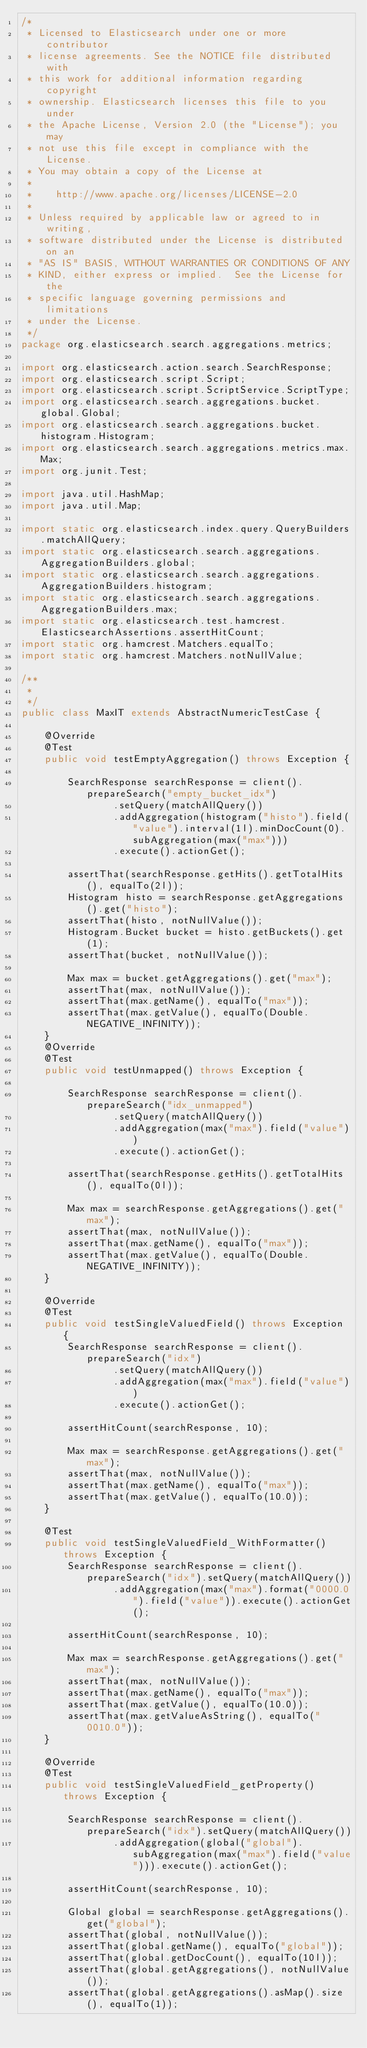Convert code to text. <code><loc_0><loc_0><loc_500><loc_500><_Java_>/*
 * Licensed to Elasticsearch under one or more contributor
 * license agreements. See the NOTICE file distributed with
 * this work for additional information regarding copyright
 * ownership. Elasticsearch licenses this file to you under
 * the Apache License, Version 2.0 (the "License"); you may
 * not use this file except in compliance with the License.
 * You may obtain a copy of the License at
 *
 *    http://www.apache.org/licenses/LICENSE-2.0
 *
 * Unless required by applicable law or agreed to in writing,
 * software distributed under the License is distributed on an
 * "AS IS" BASIS, WITHOUT WARRANTIES OR CONDITIONS OF ANY
 * KIND, either express or implied.  See the License for the
 * specific language governing permissions and limitations
 * under the License.
 */
package org.elasticsearch.search.aggregations.metrics;

import org.elasticsearch.action.search.SearchResponse;
import org.elasticsearch.script.Script;
import org.elasticsearch.script.ScriptService.ScriptType;
import org.elasticsearch.search.aggregations.bucket.global.Global;
import org.elasticsearch.search.aggregations.bucket.histogram.Histogram;
import org.elasticsearch.search.aggregations.metrics.max.Max;
import org.junit.Test;

import java.util.HashMap;
import java.util.Map;

import static org.elasticsearch.index.query.QueryBuilders.matchAllQuery;
import static org.elasticsearch.search.aggregations.AggregationBuilders.global;
import static org.elasticsearch.search.aggregations.AggregationBuilders.histogram;
import static org.elasticsearch.search.aggregations.AggregationBuilders.max;
import static org.elasticsearch.test.hamcrest.ElasticsearchAssertions.assertHitCount;
import static org.hamcrest.Matchers.equalTo;
import static org.hamcrest.Matchers.notNullValue;

/**
 *
 */
public class MaxIT extends AbstractNumericTestCase {

    @Override
    @Test
    public void testEmptyAggregation() throws Exception {

        SearchResponse searchResponse = client().prepareSearch("empty_bucket_idx")
                .setQuery(matchAllQuery())
                .addAggregation(histogram("histo").field("value").interval(1l).minDocCount(0).subAggregation(max("max")))
                .execute().actionGet();

        assertThat(searchResponse.getHits().getTotalHits(), equalTo(2l));
        Histogram histo = searchResponse.getAggregations().get("histo");
        assertThat(histo, notNullValue());
        Histogram.Bucket bucket = histo.getBuckets().get(1);
        assertThat(bucket, notNullValue());

        Max max = bucket.getAggregations().get("max");
        assertThat(max, notNullValue());
        assertThat(max.getName(), equalTo("max"));
        assertThat(max.getValue(), equalTo(Double.NEGATIVE_INFINITY));
    }
    @Override
    @Test
    public void testUnmapped() throws Exception {

        SearchResponse searchResponse = client().prepareSearch("idx_unmapped")
                .setQuery(matchAllQuery())
                .addAggregation(max("max").field("value"))
                .execute().actionGet();

        assertThat(searchResponse.getHits().getTotalHits(), equalTo(0l));

        Max max = searchResponse.getAggregations().get("max");
        assertThat(max, notNullValue());
        assertThat(max.getName(), equalTo("max"));
        assertThat(max.getValue(), equalTo(Double.NEGATIVE_INFINITY));
    }

    @Override
    @Test
    public void testSingleValuedField() throws Exception {
        SearchResponse searchResponse = client().prepareSearch("idx")
                .setQuery(matchAllQuery())
                .addAggregation(max("max").field("value"))
                .execute().actionGet();

        assertHitCount(searchResponse, 10);

        Max max = searchResponse.getAggregations().get("max");
        assertThat(max, notNullValue());
        assertThat(max.getName(), equalTo("max"));
        assertThat(max.getValue(), equalTo(10.0));
    }

    @Test
    public void testSingleValuedField_WithFormatter() throws Exception {
        SearchResponse searchResponse = client().prepareSearch("idx").setQuery(matchAllQuery())
                .addAggregation(max("max").format("0000.0").field("value")).execute().actionGet();

        assertHitCount(searchResponse, 10);

        Max max = searchResponse.getAggregations().get("max");
        assertThat(max, notNullValue());
        assertThat(max.getName(), equalTo("max"));
        assertThat(max.getValue(), equalTo(10.0));
        assertThat(max.getValueAsString(), equalTo("0010.0"));
    }

    @Override
    @Test
    public void testSingleValuedField_getProperty() throws Exception {

        SearchResponse searchResponse = client().prepareSearch("idx").setQuery(matchAllQuery())
                .addAggregation(global("global").subAggregation(max("max").field("value"))).execute().actionGet();

        assertHitCount(searchResponse, 10);

        Global global = searchResponse.getAggregations().get("global");
        assertThat(global, notNullValue());
        assertThat(global.getName(), equalTo("global"));
        assertThat(global.getDocCount(), equalTo(10l));
        assertThat(global.getAggregations(), notNullValue());
        assertThat(global.getAggregations().asMap().size(), equalTo(1));
</code> 